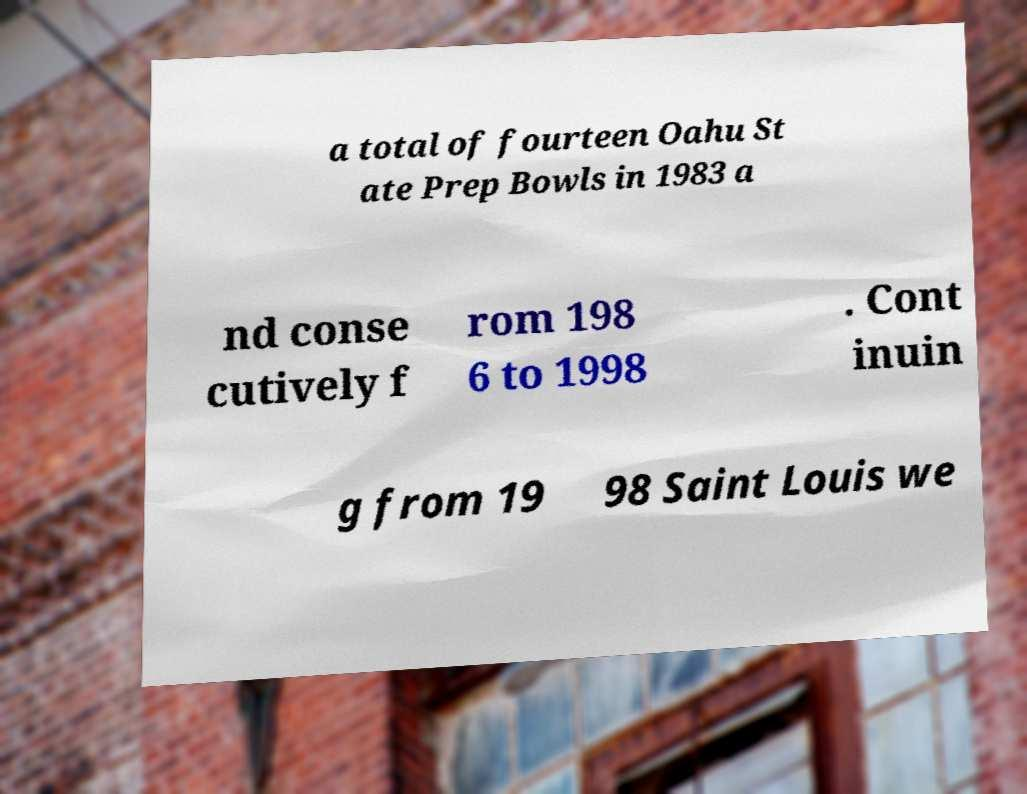Please identify and transcribe the text found in this image. a total of fourteen Oahu St ate Prep Bowls in 1983 a nd conse cutively f rom 198 6 to 1998 . Cont inuin g from 19 98 Saint Louis we 